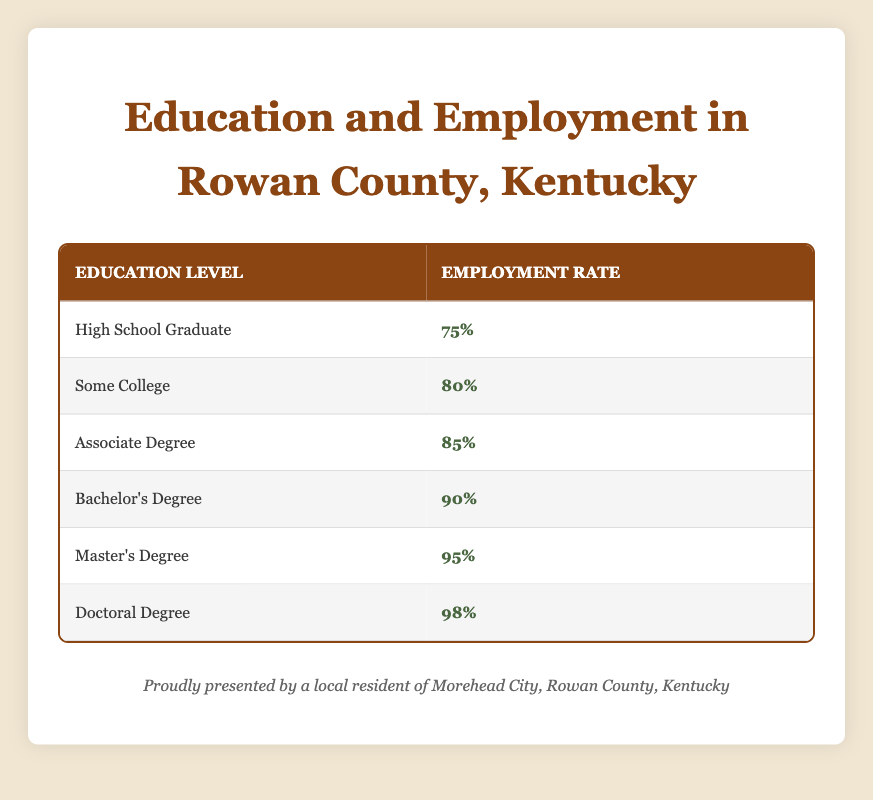What is the employment rate for someone with a Master's Degree? The table shows that the employment rate listed next to the education level "Master's Degree" is 95%. Therefore, we can directly refer to this value.
Answer: 95% How much higher is the employment rate for a Doctoral Degree compared to a High School Graduate? The employment rate for a Doctoral Degree is 98%, and for a High School Graduate, it is 75%. The difference can be calculated by subtracting: 98 - 75 = 23.
Answer: 23% Is the employment rate for someone with a Bachelor's Degree higher than 85%? The employment rate for a Bachelor's Degree is provided in the table as 90%. Since 90% is greater than 85%, the answer is true.
Answer: Yes What is the average employment rate for all education levels listed in the table? To find the average, we sum all the employment rates: 75 + 80 + 85 + 90 + 95 + 98 = 523. There are 6 education levels, so the average is 523 / 6 = 87.17.
Answer: 87.17 Does the employment rate increase consistently as the education level rises? Observing the data shows that as we move from High School Graduate to Doctoral Degree, the employment rates are increasing: 75%, 80%, 85%, 90%, 95%, 98%. There are no decreases between levels, confirming a consistent increase.
Answer: Yes What is the employment rate for someone with some college education? Looking at the table, the employment rate for "Some College" is indicated as 80%. Therefore, this value is directly retrievable from the table.
Answer: 80% If the employment rate for Associate Degree is 85%, what percentage is less than that for those with a Bachelor’s Degree? The employment rate for Bachelor's Degree is 90%. To find out how much higher it is compared to Associate Degree, we subtract: 90 - 85 = 5.
Answer: 5 Is it true that having more education reduces the likelihood of unemployment? The data indicates that increased education levels correspond to higher employment rates, suggesting that higher education levels are associated with lower unemployment. Therefore, this statement is true.
Answer: Yes 